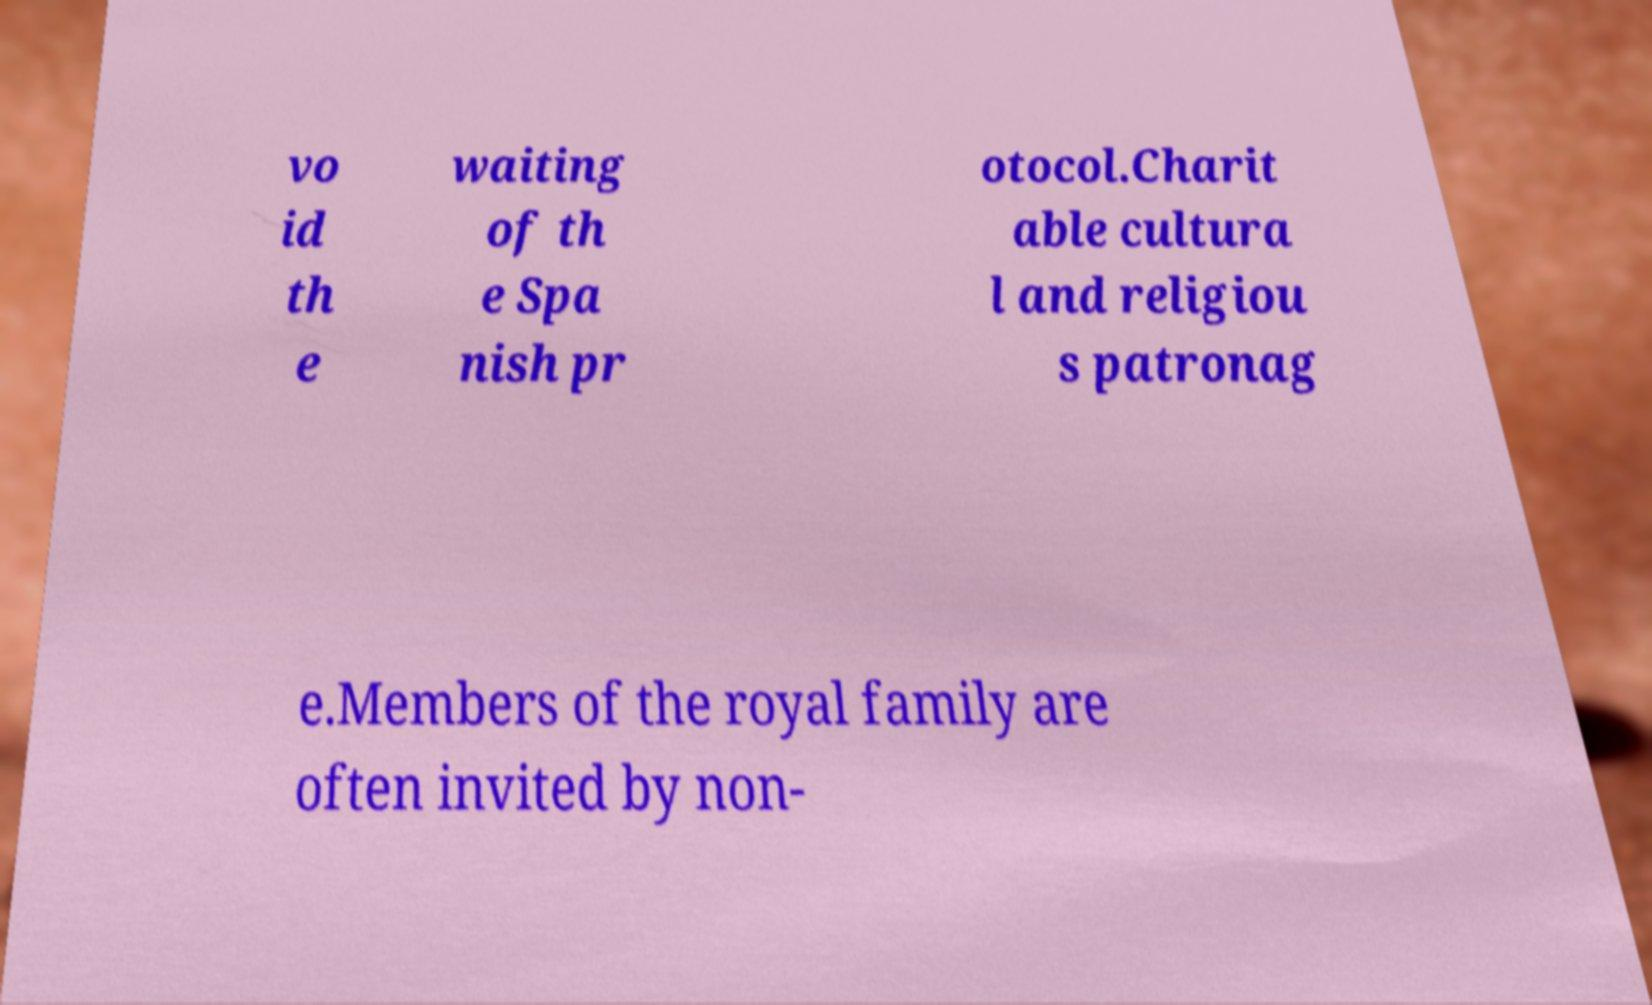Can you read and provide the text displayed in the image?This photo seems to have some interesting text. Can you extract and type it out for me? vo id th e waiting of th e Spa nish pr otocol.Charit able cultura l and religiou s patronag e.Members of the royal family are often invited by non- 